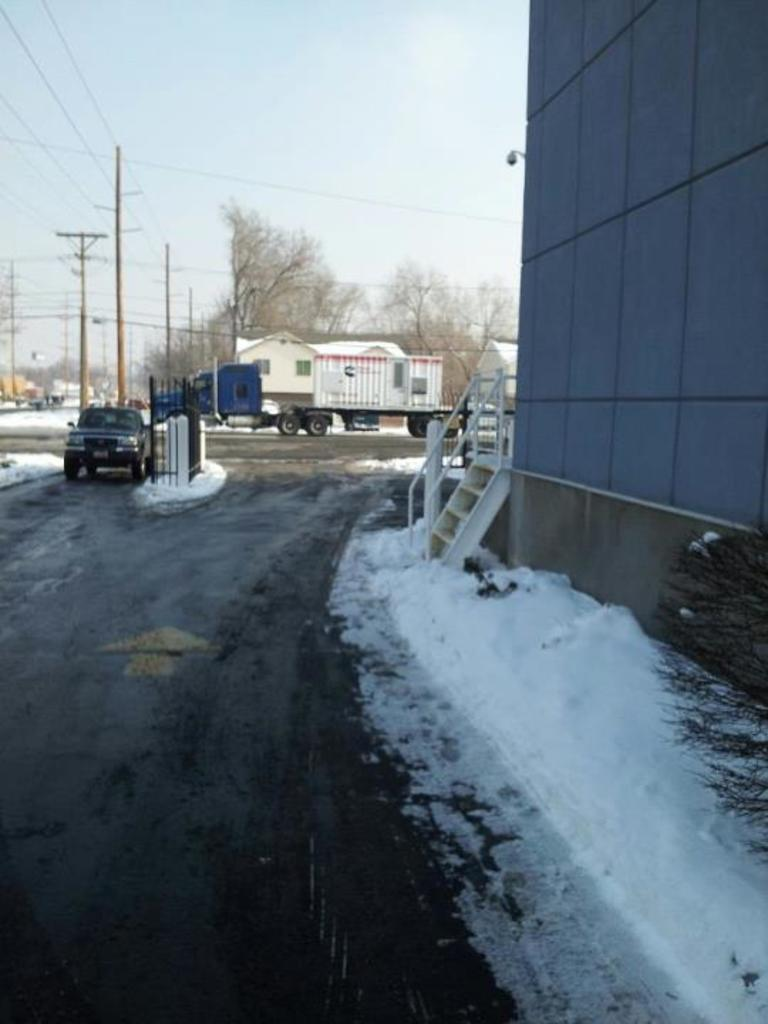What can be seen on the road in the image? There are vehicles on the road in the image. What is located near the road in the image? There is a wall visible in the image. What is the weather condition in the image? There is snow in the image, indicating a cold or wintery condition. What are the vertical structures in the image? There are poles in the image. What type of vegetation is present in the image? There are trees in the image. Can you describe the objects in the image? There are some objects in the image, but their specific nature is not mentioned in the facts. What is visible in the background of the image? The sky is visible in the background of the image. Where is the judge sitting in the image? There is no judge present in the image. What type of cushion is used for the bell in the image? There is no bell or cushion present in the image. 